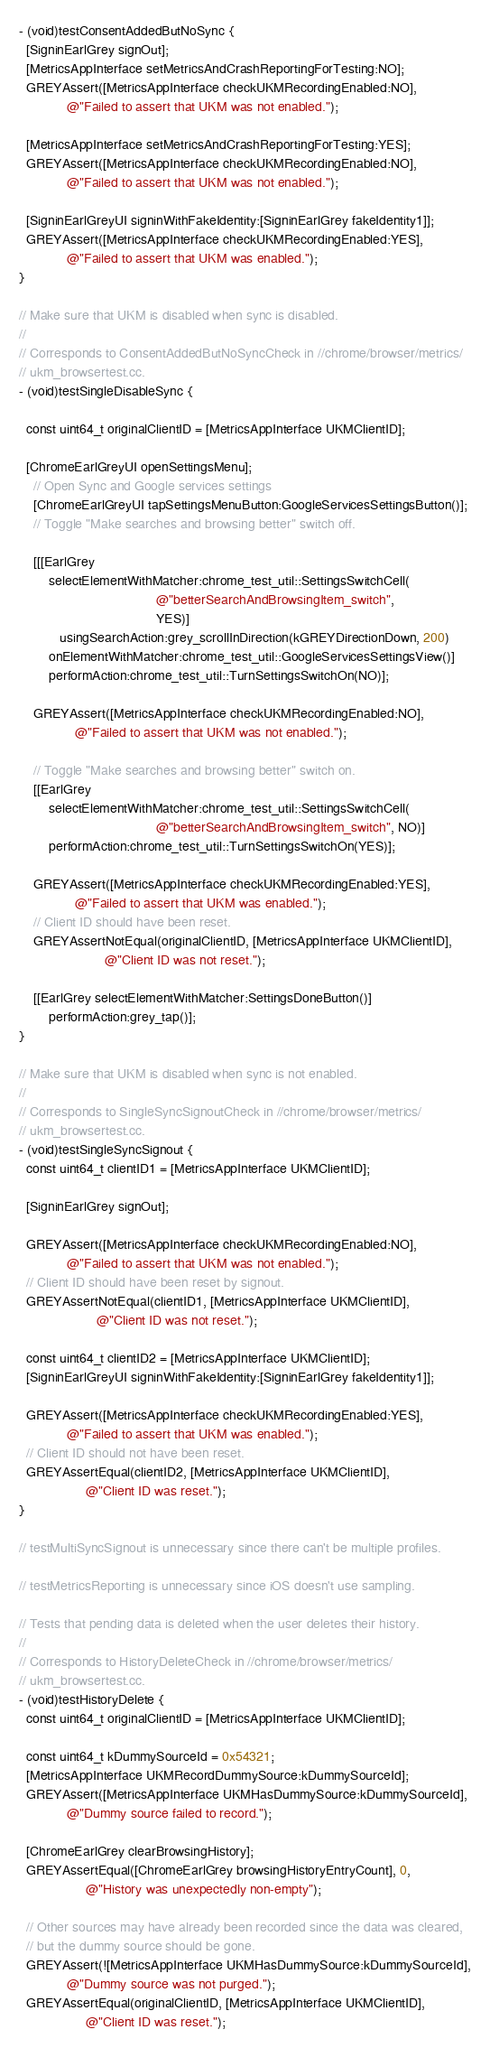<code> <loc_0><loc_0><loc_500><loc_500><_ObjectiveC_>- (void)testConsentAddedButNoSync {
  [SigninEarlGrey signOut];
  [MetricsAppInterface setMetricsAndCrashReportingForTesting:NO];
  GREYAssert([MetricsAppInterface checkUKMRecordingEnabled:NO],
             @"Failed to assert that UKM was not enabled.");

  [MetricsAppInterface setMetricsAndCrashReportingForTesting:YES];
  GREYAssert([MetricsAppInterface checkUKMRecordingEnabled:NO],
             @"Failed to assert that UKM was not enabled.");

  [SigninEarlGreyUI signinWithFakeIdentity:[SigninEarlGrey fakeIdentity1]];
  GREYAssert([MetricsAppInterface checkUKMRecordingEnabled:YES],
             @"Failed to assert that UKM was enabled.");
}

// Make sure that UKM is disabled when sync is disabled.
//
// Corresponds to ConsentAddedButNoSyncCheck in //chrome/browser/metrics/
// ukm_browsertest.cc.
- (void)testSingleDisableSync {

  const uint64_t originalClientID = [MetricsAppInterface UKMClientID];

  [ChromeEarlGreyUI openSettingsMenu];
    // Open Sync and Google services settings
    [ChromeEarlGreyUI tapSettingsMenuButton:GoogleServicesSettingsButton()];
    // Toggle "Make searches and browsing better" switch off.

    [[[EarlGrey
        selectElementWithMatcher:chrome_test_util::SettingsSwitchCell(
                                     @"betterSearchAndBrowsingItem_switch",
                                     YES)]
           usingSearchAction:grey_scrollInDirection(kGREYDirectionDown, 200)
        onElementWithMatcher:chrome_test_util::GoogleServicesSettingsView()]
        performAction:chrome_test_util::TurnSettingsSwitchOn(NO)];

    GREYAssert([MetricsAppInterface checkUKMRecordingEnabled:NO],
               @"Failed to assert that UKM was not enabled.");

    // Toggle "Make searches and browsing better" switch on.
    [[EarlGrey
        selectElementWithMatcher:chrome_test_util::SettingsSwitchCell(
                                     @"betterSearchAndBrowsingItem_switch", NO)]
        performAction:chrome_test_util::TurnSettingsSwitchOn(YES)];

    GREYAssert([MetricsAppInterface checkUKMRecordingEnabled:YES],
               @"Failed to assert that UKM was enabled.");
    // Client ID should have been reset.
    GREYAssertNotEqual(originalClientID, [MetricsAppInterface UKMClientID],
                       @"Client ID was not reset.");

    [[EarlGrey selectElementWithMatcher:SettingsDoneButton()]
        performAction:grey_tap()];
}

// Make sure that UKM is disabled when sync is not enabled.
//
// Corresponds to SingleSyncSignoutCheck in //chrome/browser/metrics/
// ukm_browsertest.cc.
- (void)testSingleSyncSignout {
  const uint64_t clientID1 = [MetricsAppInterface UKMClientID];

  [SigninEarlGrey signOut];

  GREYAssert([MetricsAppInterface checkUKMRecordingEnabled:NO],
             @"Failed to assert that UKM was not enabled.");
  // Client ID should have been reset by signout.
  GREYAssertNotEqual(clientID1, [MetricsAppInterface UKMClientID],
                     @"Client ID was not reset.");

  const uint64_t clientID2 = [MetricsAppInterface UKMClientID];
  [SigninEarlGreyUI signinWithFakeIdentity:[SigninEarlGrey fakeIdentity1]];

  GREYAssert([MetricsAppInterface checkUKMRecordingEnabled:YES],
             @"Failed to assert that UKM was enabled.");
  // Client ID should not have been reset.
  GREYAssertEqual(clientID2, [MetricsAppInterface UKMClientID],
                  @"Client ID was reset.");
}

// testMultiSyncSignout is unnecessary since there can't be multiple profiles.

// testMetricsReporting is unnecessary since iOS doesn't use sampling.

// Tests that pending data is deleted when the user deletes their history.
//
// Corresponds to HistoryDeleteCheck in //chrome/browser/metrics/
// ukm_browsertest.cc.
- (void)testHistoryDelete {
  const uint64_t originalClientID = [MetricsAppInterface UKMClientID];

  const uint64_t kDummySourceId = 0x54321;
  [MetricsAppInterface UKMRecordDummySource:kDummySourceId];
  GREYAssert([MetricsAppInterface UKMHasDummySource:kDummySourceId],
             @"Dummy source failed to record.");

  [ChromeEarlGrey clearBrowsingHistory];
  GREYAssertEqual([ChromeEarlGrey browsingHistoryEntryCount], 0,
                  @"History was unexpectedly non-empty");

  // Other sources may have already been recorded since the data was cleared,
  // but the dummy source should be gone.
  GREYAssert(![MetricsAppInterface UKMHasDummySource:kDummySourceId],
             @"Dummy source was not purged.");
  GREYAssertEqual(originalClientID, [MetricsAppInterface UKMClientID],
                  @"Client ID was reset.");</code> 